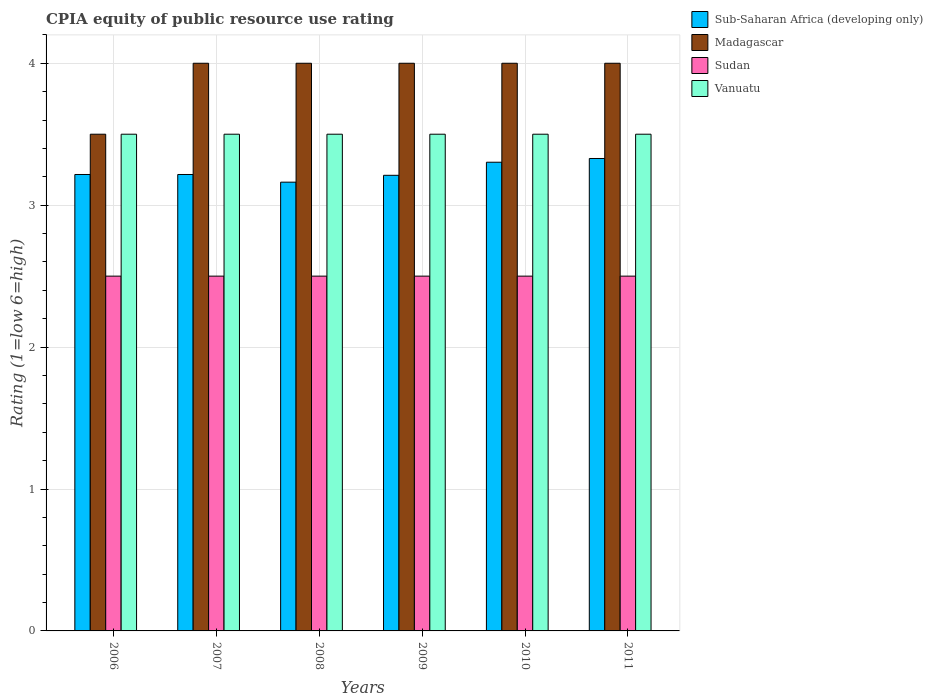How many groups of bars are there?
Your answer should be very brief. 6. Are the number of bars per tick equal to the number of legend labels?
Provide a succinct answer. Yes. How many bars are there on the 6th tick from the left?
Offer a very short reply. 4. How many bars are there on the 2nd tick from the right?
Provide a short and direct response. 4. In how many cases, is the number of bars for a given year not equal to the number of legend labels?
Provide a succinct answer. 0. What is the CPIA rating in Madagascar in 2008?
Give a very brief answer. 4. Across all years, what is the minimum CPIA rating in Vanuatu?
Your response must be concise. 3.5. In which year was the CPIA rating in Madagascar maximum?
Make the answer very short. 2007. What is the total CPIA rating in Vanuatu in the graph?
Provide a short and direct response. 21. What is the difference between the CPIA rating in Madagascar in 2007 and that in 2010?
Ensure brevity in your answer.  0. What is the difference between the CPIA rating in Sudan in 2010 and the CPIA rating in Madagascar in 2006?
Make the answer very short. -1. What is the average CPIA rating in Sub-Saharan Africa (developing only) per year?
Make the answer very short. 3.24. In the year 2008, what is the difference between the CPIA rating in Sub-Saharan Africa (developing only) and CPIA rating in Vanuatu?
Offer a terse response. -0.34. Is the difference between the CPIA rating in Sub-Saharan Africa (developing only) in 2008 and 2011 greater than the difference between the CPIA rating in Vanuatu in 2008 and 2011?
Offer a terse response. No. Is the sum of the CPIA rating in Vanuatu in 2010 and 2011 greater than the maximum CPIA rating in Sub-Saharan Africa (developing only) across all years?
Keep it short and to the point. Yes. Is it the case that in every year, the sum of the CPIA rating in Vanuatu and CPIA rating in Sudan is greater than the sum of CPIA rating in Sub-Saharan Africa (developing only) and CPIA rating in Madagascar?
Keep it short and to the point. No. What does the 3rd bar from the left in 2010 represents?
Your answer should be compact. Sudan. What does the 2nd bar from the right in 2006 represents?
Ensure brevity in your answer.  Sudan. Is it the case that in every year, the sum of the CPIA rating in Madagascar and CPIA rating in Vanuatu is greater than the CPIA rating in Sudan?
Provide a short and direct response. Yes. How many bars are there?
Your answer should be very brief. 24. What is the difference between two consecutive major ticks on the Y-axis?
Offer a terse response. 1. Are the values on the major ticks of Y-axis written in scientific E-notation?
Offer a terse response. No. Does the graph contain grids?
Ensure brevity in your answer.  Yes. Where does the legend appear in the graph?
Offer a very short reply. Top right. How many legend labels are there?
Offer a very short reply. 4. What is the title of the graph?
Keep it short and to the point. CPIA equity of public resource use rating. What is the label or title of the X-axis?
Offer a very short reply. Years. What is the label or title of the Y-axis?
Provide a short and direct response. Rating (1=low 6=high). What is the Rating (1=low 6=high) of Sub-Saharan Africa (developing only) in 2006?
Your response must be concise. 3.22. What is the Rating (1=low 6=high) of Sub-Saharan Africa (developing only) in 2007?
Keep it short and to the point. 3.22. What is the Rating (1=low 6=high) of Vanuatu in 2007?
Keep it short and to the point. 3.5. What is the Rating (1=low 6=high) of Sub-Saharan Africa (developing only) in 2008?
Give a very brief answer. 3.16. What is the Rating (1=low 6=high) in Madagascar in 2008?
Provide a succinct answer. 4. What is the Rating (1=low 6=high) in Sub-Saharan Africa (developing only) in 2009?
Ensure brevity in your answer.  3.21. What is the Rating (1=low 6=high) of Sudan in 2009?
Make the answer very short. 2.5. What is the Rating (1=low 6=high) in Sub-Saharan Africa (developing only) in 2010?
Your response must be concise. 3.3. What is the Rating (1=low 6=high) in Madagascar in 2010?
Offer a very short reply. 4. What is the Rating (1=low 6=high) of Sub-Saharan Africa (developing only) in 2011?
Give a very brief answer. 3.33. What is the Rating (1=low 6=high) in Madagascar in 2011?
Your answer should be very brief. 4. What is the Rating (1=low 6=high) of Sudan in 2011?
Your answer should be very brief. 2.5. What is the Rating (1=low 6=high) of Vanuatu in 2011?
Provide a succinct answer. 3.5. Across all years, what is the maximum Rating (1=low 6=high) of Sub-Saharan Africa (developing only)?
Ensure brevity in your answer.  3.33. Across all years, what is the maximum Rating (1=low 6=high) in Madagascar?
Offer a terse response. 4. Across all years, what is the maximum Rating (1=low 6=high) of Vanuatu?
Your answer should be very brief. 3.5. Across all years, what is the minimum Rating (1=low 6=high) of Sub-Saharan Africa (developing only)?
Your answer should be very brief. 3.16. Across all years, what is the minimum Rating (1=low 6=high) in Madagascar?
Offer a very short reply. 3.5. Across all years, what is the minimum Rating (1=low 6=high) in Vanuatu?
Your response must be concise. 3.5. What is the total Rating (1=low 6=high) in Sub-Saharan Africa (developing only) in the graph?
Offer a very short reply. 19.44. What is the total Rating (1=low 6=high) of Madagascar in the graph?
Provide a succinct answer. 23.5. What is the total Rating (1=low 6=high) of Sudan in the graph?
Provide a succinct answer. 15. What is the difference between the Rating (1=low 6=high) of Madagascar in 2006 and that in 2007?
Make the answer very short. -0.5. What is the difference between the Rating (1=low 6=high) in Sudan in 2006 and that in 2007?
Your answer should be very brief. 0. What is the difference between the Rating (1=low 6=high) of Sub-Saharan Africa (developing only) in 2006 and that in 2008?
Keep it short and to the point. 0.05. What is the difference between the Rating (1=low 6=high) of Sudan in 2006 and that in 2008?
Give a very brief answer. 0. What is the difference between the Rating (1=low 6=high) in Vanuatu in 2006 and that in 2008?
Your answer should be very brief. 0. What is the difference between the Rating (1=low 6=high) of Sub-Saharan Africa (developing only) in 2006 and that in 2009?
Ensure brevity in your answer.  0.01. What is the difference between the Rating (1=low 6=high) of Madagascar in 2006 and that in 2009?
Provide a short and direct response. -0.5. What is the difference between the Rating (1=low 6=high) in Vanuatu in 2006 and that in 2009?
Your response must be concise. 0. What is the difference between the Rating (1=low 6=high) of Sub-Saharan Africa (developing only) in 2006 and that in 2010?
Your answer should be very brief. -0.09. What is the difference between the Rating (1=low 6=high) of Vanuatu in 2006 and that in 2010?
Ensure brevity in your answer.  0. What is the difference between the Rating (1=low 6=high) in Sub-Saharan Africa (developing only) in 2006 and that in 2011?
Make the answer very short. -0.11. What is the difference between the Rating (1=low 6=high) in Madagascar in 2006 and that in 2011?
Offer a terse response. -0.5. What is the difference between the Rating (1=low 6=high) in Sudan in 2006 and that in 2011?
Your answer should be very brief. 0. What is the difference between the Rating (1=low 6=high) in Sub-Saharan Africa (developing only) in 2007 and that in 2008?
Your response must be concise. 0.05. What is the difference between the Rating (1=low 6=high) in Madagascar in 2007 and that in 2008?
Offer a very short reply. 0. What is the difference between the Rating (1=low 6=high) in Sudan in 2007 and that in 2008?
Your answer should be compact. 0. What is the difference between the Rating (1=low 6=high) of Sub-Saharan Africa (developing only) in 2007 and that in 2009?
Offer a terse response. 0.01. What is the difference between the Rating (1=low 6=high) of Vanuatu in 2007 and that in 2009?
Your answer should be very brief. 0. What is the difference between the Rating (1=low 6=high) in Sub-Saharan Africa (developing only) in 2007 and that in 2010?
Provide a short and direct response. -0.09. What is the difference between the Rating (1=low 6=high) of Madagascar in 2007 and that in 2010?
Your answer should be very brief. 0. What is the difference between the Rating (1=low 6=high) of Sudan in 2007 and that in 2010?
Your answer should be compact. 0. What is the difference between the Rating (1=low 6=high) in Sub-Saharan Africa (developing only) in 2007 and that in 2011?
Your response must be concise. -0.11. What is the difference between the Rating (1=low 6=high) of Madagascar in 2007 and that in 2011?
Ensure brevity in your answer.  0. What is the difference between the Rating (1=low 6=high) of Sub-Saharan Africa (developing only) in 2008 and that in 2009?
Offer a terse response. -0.05. What is the difference between the Rating (1=low 6=high) of Sudan in 2008 and that in 2009?
Provide a succinct answer. 0. What is the difference between the Rating (1=low 6=high) of Vanuatu in 2008 and that in 2009?
Provide a short and direct response. 0. What is the difference between the Rating (1=low 6=high) in Sub-Saharan Africa (developing only) in 2008 and that in 2010?
Ensure brevity in your answer.  -0.14. What is the difference between the Rating (1=low 6=high) in Madagascar in 2008 and that in 2010?
Give a very brief answer. 0. What is the difference between the Rating (1=low 6=high) of Sudan in 2008 and that in 2010?
Offer a very short reply. 0. What is the difference between the Rating (1=low 6=high) in Vanuatu in 2008 and that in 2010?
Your answer should be very brief. 0. What is the difference between the Rating (1=low 6=high) of Sub-Saharan Africa (developing only) in 2008 and that in 2011?
Give a very brief answer. -0.17. What is the difference between the Rating (1=low 6=high) in Vanuatu in 2008 and that in 2011?
Your response must be concise. 0. What is the difference between the Rating (1=low 6=high) of Sub-Saharan Africa (developing only) in 2009 and that in 2010?
Offer a very short reply. -0.09. What is the difference between the Rating (1=low 6=high) of Vanuatu in 2009 and that in 2010?
Provide a succinct answer. 0. What is the difference between the Rating (1=low 6=high) of Sub-Saharan Africa (developing only) in 2009 and that in 2011?
Make the answer very short. -0.12. What is the difference between the Rating (1=low 6=high) of Madagascar in 2009 and that in 2011?
Provide a short and direct response. 0. What is the difference between the Rating (1=low 6=high) of Sudan in 2009 and that in 2011?
Provide a succinct answer. 0. What is the difference between the Rating (1=low 6=high) of Vanuatu in 2009 and that in 2011?
Your answer should be very brief. 0. What is the difference between the Rating (1=low 6=high) of Sub-Saharan Africa (developing only) in 2010 and that in 2011?
Provide a short and direct response. -0.03. What is the difference between the Rating (1=low 6=high) in Madagascar in 2010 and that in 2011?
Make the answer very short. 0. What is the difference between the Rating (1=low 6=high) of Vanuatu in 2010 and that in 2011?
Ensure brevity in your answer.  0. What is the difference between the Rating (1=low 6=high) of Sub-Saharan Africa (developing only) in 2006 and the Rating (1=low 6=high) of Madagascar in 2007?
Give a very brief answer. -0.78. What is the difference between the Rating (1=low 6=high) of Sub-Saharan Africa (developing only) in 2006 and the Rating (1=low 6=high) of Sudan in 2007?
Ensure brevity in your answer.  0.72. What is the difference between the Rating (1=low 6=high) in Sub-Saharan Africa (developing only) in 2006 and the Rating (1=low 6=high) in Vanuatu in 2007?
Make the answer very short. -0.28. What is the difference between the Rating (1=low 6=high) in Madagascar in 2006 and the Rating (1=low 6=high) in Vanuatu in 2007?
Your response must be concise. 0. What is the difference between the Rating (1=low 6=high) in Sudan in 2006 and the Rating (1=low 6=high) in Vanuatu in 2007?
Your answer should be compact. -1. What is the difference between the Rating (1=low 6=high) of Sub-Saharan Africa (developing only) in 2006 and the Rating (1=low 6=high) of Madagascar in 2008?
Make the answer very short. -0.78. What is the difference between the Rating (1=low 6=high) in Sub-Saharan Africa (developing only) in 2006 and the Rating (1=low 6=high) in Sudan in 2008?
Offer a terse response. 0.72. What is the difference between the Rating (1=low 6=high) of Sub-Saharan Africa (developing only) in 2006 and the Rating (1=low 6=high) of Vanuatu in 2008?
Ensure brevity in your answer.  -0.28. What is the difference between the Rating (1=low 6=high) of Sub-Saharan Africa (developing only) in 2006 and the Rating (1=low 6=high) of Madagascar in 2009?
Offer a terse response. -0.78. What is the difference between the Rating (1=low 6=high) in Sub-Saharan Africa (developing only) in 2006 and the Rating (1=low 6=high) in Sudan in 2009?
Offer a very short reply. 0.72. What is the difference between the Rating (1=low 6=high) of Sub-Saharan Africa (developing only) in 2006 and the Rating (1=low 6=high) of Vanuatu in 2009?
Give a very brief answer. -0.28. What is the difference between the Rating (1=low 6=high) in Madagascar in 2006 and the Rating (1=low 6=high) in Sudan in 2009?
Your answer should be very brief. 1. What is the difference between the Rating (1=low 6=high) of Madagascar in 2006 and the Rating (1=low 6=high) of Vanuatu in 2009?
Offer a very short reply. 0. What is the difference between the Rating (1=low 6=high) of Sub-Saharan Africa (developing only) in 2006 and the Rating (1=low 6=high) of Madagascar in 2010?
Provide a succinct answer. -0.78. What is the difference between the Rating (1=low 6=high) in Sub-Saharan Africa (developing only) in 2006 and the Rating (1=low 6=high) in Sudan in 2010?
Give a very brief answer. 0.72. What is the difference between the Rating (1=low 6=high) of Sub-Saharan Africa (developing only) in 2006 and the Rating (1=low 6=high) of Vanuatu in 2010?
Make the answer very short. -0.28. What is the difference between the Rating (1=low 6=high) in Sudan in 2006 and the Rating (1=low 6=high) in Vanuatu in 2010?
Provide a short and direct response. -1. What is the difference between the Rating (1=low 6=high) in Sub-Saharan Africa (developing only) in 2006 and the Rating (1=low 6=high) in Madagascar in 2011?
Your response must be concise. -0.78. What is the difference between the Rating (1=low 6=high) in Sub-Saharan Africa (developing only) in 2006 and the Rating (1=low 6=high) in Sudan in 2011?
Ensure brevity in your answer.  0.72. What is the difference between the Rating (1=low 6=high) in Sub-Saharan Africa (developing only) in 2006 and the Rating (1=low 6=high) in Vanuatu in 2011?
Provide a succinct answer. -0.28. What is the difference between the Rating (1=low 6=high) of Madagascar in 2006 and the Rating (1=low 6=high) of Sudan in 2011?
Your response must be concise. 1. What is the difference between the Rating (1=low 6=high) in Sudan in 2006 and the Rating (1=low 6=high) in Vanuatu in 2011?
Keep it short and to the point. -1. What is the difference between the Rating (1=low 6=high) of Sub-Saharan Africa (developing only) in 2007 and the Rating (1=low 6=high) of Madagascar in 2008?
Keep it short and to the point. -0.78. What is the difference between the Rating (1=low 6=high) in Sub-Saharan Africa (developing only) in 2007 and the Rating (1=low 6=high) in Sudan in 2008?
Keep it short and to the point. 0.72. What is the difference between the Rating (1=low 6=high) of Sub-Saharan Africa (developing only) in 2007 and the Rating (1=low 6=high) of Vanuatu in 2008?
Offer a terse response. -0.28. What is the difference between the Rating (1=low 6=high) of Madagascar in 2007 and the Rating (1=low 6=high) of Sudan in 2008?
Offer a very short reply. 1.5. What is the difference between the Rating (1=low 6=high) in Madagascar in 2007 and the Rating (1=low 6=high) in Vanuatu in 2008?
Your response must be concise. 0.5. What is the difference between the Rating (1=low 6=high) of Sudan in 2007 and the Rating (1=low 6=high) of Vanuatu in 2008?
Provide a succinct answer. -1. What is the difference between the Rating (1=low 6=high) of Sub-Saharan Africa (developing only) in 2007 and the Rating (1=low 6=high) of Madagascar in 2009?
Provide a short and direct response. -0.78. What is the difference between the Rating (1=low 6=high) in Sub-Saharan Africa (developing only) in 2007 and the Rating (1=low 6=high) in Sudan in 2009?
Keep it short and to the point. 0.72. What is the difference between the Rating (1=low 6=high) of Sub-Saharan Africa (developing only) in 2007 and the Rating (1=low 6=high) of Vanuatu in 2009?
Provide a short and direct response. -0.28. What is the difference between the Rating (1=low 6=high) of Madagascar in 2007 and the Rating (1=low 6=high) of Vanuatu in 2009?
Provide a succinct answer. 0.5. What is the difference between the Rating (1=low 6=high) in Sub-Saharan Africa (developing only) in 2007 and the Rating (1=low 6=high) in Madagascar in 2010?
Offer a very short reply. -0.78. What is the difference between the Rating (1=low 6=high) of Sub-Saharan Africa (developing only) in 2007 and the Rating (1=low 6=high) of Sudan in 2010?
Offer a very short reply. 0.72. What is the difference between the Rating (1=low 6=high) of Sub-Saharan Africa (developing only) in 2007 and the Rating (1=low 6=high) of Vanuatu in 2010?
Keep it short and to the point. -0.28. What is the difference between the Rating (1=low 6=high) of Madagascar in 2007 and the Rating (1=low 6=high) of Vanuatu in 2010?
Give a very brief answer. 0.5. What is the difference between the Rating (1=low 6=high) of Sudan in 2007 and the Rating (1=low 6=high) of Vanuatu in 2010?
Your answer should be very brief. -1. What is the difference between the Rating (1=low 6=high) in Sub-Saharan Africa (developing only) in 2007 and the Rating (1=low 6=high) in Madagascar in 2011?
Offer a very short reply. -0.78. What is the difference between the Rating (1=low 6=high) in Sub-Saharan Africa (developing only) in 2007 and the Rating (1=low 6=high) in Sudan in 2011?
Ensure brevity in your answer.  0.72. What is the difference between the Rating (1=low 6=high) in Sub-Saharan Africa (developing only) in 2007 and the Rating (1=low 6=high) in Vanuatu in 2011?
Offer a terse response. -0.28. What is the difference between the Rating (1=low 6=high) of Sub-Saharan Africa (developing only) in 2008 and the Rating (1=low 6=high) of Madagascar in 2009?
Give a very brief answer. -0.84. What is the difference between the Rating (1=low 6=high) of Sub-Saharan Africa (developing only) in 2008 and the Rating (1=low 6=high) of Sudan in 2009?
Offer a very short reply. 0.66. What is the difference between the Rating (1=low 6=high) in Sub-Saharan Africa (developing only) in 2008 and the Rating (1=low 6=high) in Vanuatu in 2009?
Keep it short and to the point. -0.34. What is the difference between the Rating (1=low 6=high) of Madagascar in 2008 and the Rating (1=low 6=high) of Sudan in 2009?
Give a very brief answer. 1.5. What is the difference between the Rating (1=low 6=high) in Madagascar in 2008 and the Rating (1=low 6=high) in Vanuatu in 2009?
Give a very brief answer. 0.5. What is the difference between the Rating (1=low 6=high) of Sub-Saharan Africa (developing only) in 2008 and the Rating (1=low 6=high) of Madagascar in 2010?
Your response must be concise. -0.84. What is the difference between the Rating (1=low 6=high) of Sub-Saharan Africa (developing only) in 2008 and the Rating (1=low 6=high) of Sudan in 2010?
Offer a terse response. 0.66. What is the difference between the Rating (1=low 6=high) of Sub-Saharan Africa (developing only) in 2008 and the Rating (1=low 6=high) of Vanuatu in 2010?
Give a very brief answer. -0.34. What is the difference between the Rating (1=low 6=high) of Madagascar in 2008 and the Rating (1=low 6=high) of Sudan in 2010?
Give a very brief answer. 1.5. What is the difference between the Rating (1=low 6=high) of Madagascar in 2008 and the Rating (1=low 6=high) of Vanuatu in 2010?
Give a very brief answer. 0.5. What is the difference between the Rating (1=low 6=high) of Sudan in 2008 and the Rating (1=low 6=high) of Vanuatu in 2010?
Provide a short and direct response. -1. What is the difference between the Rating (1=low 6=high) of Sub-Saharan Africa (developing only) in 2008 and the Rating (1=low 6=high) of Madagascar in 2011?
Your answer should be very brief. -0.84. What is the difference between the Rating (1=low 6=high) in Sub-Saharan Africa (developing only) in 2008 and the Rating (1=low 6=high) in Sudan in 2011?
Provide a succinct answer. 0.66. What is the difference between the Rating (1=low 6=high) of Sub-Saharan Africa (developing only) in 2008 and the Rating (1=low 6=high) of Vanuatu in 2011?
Your answer should be very brief. -0.34. What is the difference between the Rating (1=low 6=high) in Sudan in 2008 and the Rating (1=low 6=high) in Vanuatu in 2011?
Offer a very short reply. -1. What is the difference between the Rating (1=low 6=high) of Sub-Saharan Africa (developing only) in 2009 and the Rating (1=low 6=high) of Madagascar in 2010?
Offer a terse response. -0.79. What is the difference between the Rating (1=low 6=high) in Sub-Saharan Africa (developing only) in 2009 and the Rating (1=low 6=high) in Sudan in 2010?
Make the answer very short. 0.71. What is the difference between the Rating (1=low 6=high) of Sub-Saharan Africa (developing only) in 2009 and the Rating (1=low 6=high) of Vanuatu in 2010?
Keep it short and to the point. -0.29. What is the difference between the Rating (1=low 6=high) in Madagascar in 2009 and the Rating (1=low 6=high) in Sudan in 2010?
Give a very brief answer. 1.5. What is the difference between the Rating (1=low 6=high) in Madagascar in 2009 and the Rating (1=low 6=high) in Vanuatu in 2010?
Provide a succinct answer. 0.5. What is the difference between the Rating (1=low 6=high) of Sudan in 2009 and the Rating (1=low 6=high) of Vanuatu in 2010?
Ensure brevity in your answer.  -1. What is the difference between the Rating (1=low 6=high) of Sub-Saharan Africa (developing only) in 2009 and the Rating (1=low 6=high) of Madagascar in 2011?
Your answer should be compact. -0.79. What is the difference between the Rating (1=low 6=high) of Sub-Saharan Africa (developing only) in 2009 and the Rating (1=low 6=high) of Sudan in 2011?
Your answer should be compact. 0.71. What is the difference between the Rating (1=low 6=high) of Sub-Saharan Africa (developing only) in 2009 and the Rating (1=low 6=high) of Vanuatu in 2011?
Your response must be concise. -0.29. What is the difference between the Rating (1=low 6=high) of Madagascar in 2009 and the Rating (1=low 6=high) of Sudan in 2011?
Give a very brief answer. 1.5. What is the difference between the Rating (1=low 6=high) of Madagascar in 2009 and the Rating (1=low 6=high) of Vanuatu in 2011?
Your response must be concise. 0.5. What is the difference between the Rating (1=low 6=high) in Sub-Saharan Africa (developing only) in 2010 and the Rating (1=low 6=high) in Madagascar in 2011?
Offer a terse response. -0.7. What is the difference between the Rating (1=low 6=high) in Sub-Saharan Africa (developing only) in 2010 and the Rating (1=low 6=high) in Sudan in 2011?
Your answer should be compact. 0.8. What is the difference between the Rating (1=low 6=high) in Sub-Saharan Africa (developing only) in 2010 and the Rating (1=low 6=high) in Vanuatu in 2011?
Make the answer very short. -0.2. What is the difference between the Rating (1=low 6=high) of Madagascar in 2010 and the Rating (1=low 6=high) of Sudan in 2011?
Make the answer very short. 1.5. What is the difference between the Rating (1=low 6=high) of Sudan in 2010 and the Rating (1=low 6=high) of Vanuatu in 2011?
Your response must be concise. -1. What is the average Rating (1=low 6=high) of Sub-Saharan Africa (developing only) per year?
Your answer should be very brief. 3.24. What is the average Rating (1=low 6=high) of Madagascar per year?
Make the answer very short. 3.92. What is the average Rating (1=low 6=high) in Sudan per year?
Offer a terse response. 2.5. In the year 2006, what is the difference between the Rating (1=low 6=high) of Sub-Saharan Africa (developing only) and Rating (1=low 6=high) of Madagascar?
Offer a very short reply. -0.28. In the year 2006, what is the difference between the Rating (1=low 6=high) in Sub-Saharan Africa (developing only) and Rating (1=low 6=high) in Sudan?
Offer a terse response. 0.72. In the year 2006, what is the difference between the Rating (1=low 6=high) of Sub-Saharan Africa (developing only) and Rating (1=low 6=high) of Vanuatu?
Offer a terse response. -0.28. In the year 2007, what is the difference between the Rating (1=low 6=high) in Sub-Saharan Africa (developing only) and Rating (1=low 6=high) in Madagascar?
Your answer should be very brief. -0.78. In the year 2007, what is the difference between the Rating (1=low 6=high) of Sub-Saharan Africa (developing only) and Rating (1=low 6=high) of Sudan?
Provide a succinct answer. 0.72. In the year 2007, what is the difference between the Rating (1=low 6=high) in Sub-Saharan Africa (developing only) and Rating (1=low 6=high) in Vanuatu?
Give a very brief answer. -0.28. In the year 2008, what is the difference between the Rating (1=low 6=high) of Sub-Saharan Africa (developing only) and Rating (1=low 6=high) of Madagascar?
Keep it short and to the point. -0.84. In the year 2008, what is the difference between the Rating (1=low 6=high) in Sub-Saharan Africa (developing only) and Rating (1=low 6=high) in Sudan?
Keep it short and to the point. 0.66. In the year 2008, what is the difference between the Rating (1=low 6=high) of Sub-Saharan Africa (developing only) and Rating (1=low 6=high) of Vanuatu?
Give a very brief answer. -0.34. In the year 2008, what is the difference between the Rating (1=low 6=high) of Sudan and Rating (1=low 6=high) of Vanuatu?
Your response must be concise. -1. In the year 2009, what is the difference between the Rating (1=low 6=high) in Sub-Saharan Africa (developing only) and Rating (1=low 6=high) in Madagascar?
Ensure brevity in your answer.  -0.79. In the year 2009, what is the difference between the Rating (1=low 6=high) in Sub-Saharan Africa (developing only) and Rating (1=low 6=high) in Sudan?
Give a very brief answer. 0.71. In the year 2009, what is the difference between the Rating (1=low 6=high) in Sub-Saharan Africa (developing only) and Rating (1=low 6=high) in Vanuatu?
Your answer should be very brief. -0.29. In the year 2009, what is the difference between the Rating (1=low 6=high) of Madagascar and Rating (1=low 6=high) of Sudan?
Keep it short and to the point. 1.5. In the year 2010, what is the difference between the Rating (1=low 6=high) of Sub-Saharan Africa (developing only) and Rating (1=low 6=high) of Madagascar?
Offer a terse response. -0.7. In the year 2010, what is the difference between the Rating (1=low 6=high) in Sub-Saharan Africa (developing only) and Rating (1=low 6=high) in Sudan?
Your answer should be compact. 0.8. In the year 2010, what is the difference between the Rating (1=low 6=high) of Sub-Saharan Africa (developing only) and Rating (1=low 6=high) of Vanuatu?
Offer a terse response. -0.2. In the year 2010, what is the difference between the Rating (1=low 6=high) of Madagascar and Rating (1=low 6=high) of Sudan?
Provide a succinct answer. 1.5. In the year 2010, what is the difference between the Rating (1=low 6=high) in Sudan and Rating (1=low 6=high) in Vanuatu?
Your answer should be very brief. -1. In the year 2011, what is the difference between the Rating (1=low 6=high) in Sub-Saharan Africa (developing only) and Rating (1=low 6=high) in Madagascar?
Offer a very short reply. -0.67. In the year 2011, what is the difference between the Rating (1=low 6=high) in Sub-Saharan Africa (developing only) and Rating (1=low 6=high) in Sudan?
Your answer should be compact. 0.83. In the year 2011, what is the difference between the Rating (1=low 6=high) in Sub-Saharan Africa (developing only) and Rating (1=low 6=high) in Vanuatu?
Provide a succinct answer. -0.17. In the year 2011, what is the difference between the Rating (1=low 6=high) of Madagascar and Rating (1=low 6=high) of Vanuatu?
Ensure brevity in your answer.  0.5. What is the ratio of the Rating (1=low 6=high) of Madagascar in 2006 to that in 2007?
Give a very brief answer. 0.88. What is the ratio of the Rating (1=low 6=high) in Sudan in 2006 to that in 2007?
Your answer should be compact. 1. What is the ratio of the Rating (1=low 6=high) of Sub-Saharan Africa (developing only) in 2006 to that in 2008?
Make the answer very short. 1.02. What is the ratio of the Rating (1=low 6=high) in Vanuatu in 2006 to that in 2008?
Give a very brief answer. 1. What is the ratio of the Rating (1=low 6=high) of Sudan in 2006 to that in 2009?
Offer a very short reply. 1. What is the ratio of the Rating (1=low 6=high) of Sub-Saharan Africa (developing only) in 2006 to that in 2010?
Ensure brevity in your answer.  0.97. What is the ratio of the Rating (1=low 6=high) in Sudan in 2006 to that in 2010?
Your answer should be very brief. 1. What is the ratio of the Rating (1=low 6=high) in Sub-Saharan Africa (developing only) in 2006 to that in 2011?
Your response must be concise. 0.97. What is the ratio of the Rating (1=low 6=high) in Sudan in 2006 to that in 2011?
Ensure brevity in your answer.  1. What is the ratio of the Rating (1=low 6=high) of Vanuatu in 2006 to that in 2011?
Offer a very short reply. 1. What is the ratio of the Rating (1=low 6=high) of Sub-Saharan Africa (developing only) in 2007 to that in 2008?
Your answer should be very brief. 1.02. What is the ratio of the Rating (1=low 6=high) of Madagascar in 2007 to that in 2008?
Your answer should be compact. 1. What is the ratio of the Rating (1=low 6=high) in Vanuatu in 2007 to that in 2008?
Your answer should be very brief. 1. What is the ratio of the Rating (1=low 6=high) in Sub-Saharan Africa (developing only) in 2007 to that in 2009?
Keep it short and to the point. 1. What is the ratio of the Rating (1=low 6=high) of Madagascar in 2007 to that in 2009?
Your answer should be compact. 1. What is the ratio of the Rating (1=low 6=high) of Sudan in 2007 to that in 2009?
Offer a very short reply. 1. What is the ratio of the Rating (1=low 6=high) of Vanuatu in 2007 to that in 2009?
Provide a succinct answer. 1. What is the ratio of the Rating (1=low 6=high) in Sub-Saharan Africa (developing only) in 2007 to that in 2010?
Your answer should be very brief. 0.97. What is the ratio of the Rating (1=low 6=high) of Madagascar in 2007 to that in 2010?
Keep it short and to the point. 1. What is the ratio of the Rating (1=low 6=high) in Sudan in 2007 to that in 2010?
Ensure brevity in your answer.  1. What is the ratio of the Rating (1=low 6=high) in Sub-Saharan Africa (developing only) in 2007 to that in 2011?
Your answer should be very brief. 0.97. What is the ratio of the Rating (1=low 6=high) of Vanuatu in 2007 to that in 2011?
Give a very brief answer. 1. What is the ratio of the Rating (1=low 6=high) of Sub-Saharan Africa (developing only) in 2008 to that in 2009?
Your answer should be compact. 0.98. What is the ratio of the Rating (1=low 6=high) in Madagascar in 2008 to that in 2009?
Make the answer very short. 1. What is the ratio of the Rating (1=low 6=high) in Sudan in 2008 to that in 2009?
Make the answer very short. 1. What is the ratio of the Rating (1=low 6=high) in Vanuatu in 2008 to that in 2009?
Give a very brief answer. 1. What is the ratio of the Rating (1=low 6=high) of Sub-Saharan Africa (developing only) in 2008 to that in 2010?
Provide a short and direct response. 0.96. What is the ratio of the Rating (1=low 6=high) in Vanuatu in 2008 to that in 2010?
Your response must be concise. 1. What is the ratio of the Rating (1=low 6=high) in Sub-Saharan Africa (developing only) in 2008 to that in 2011?
Your answer should be compact. 0.95. What is the ratio of the Rating (1=low 6=high) of Madagascar in 2008 to that in 2011?
Your response must be concise. 1. What is the ratio of the Rating (1=low 6=high) of Vanuatu in 2008 to that in 2011?
Keep it short and to the point. 1. What is the ratio of the Rating (1=low 6=high) in Sub-Saharan Africa (developing only) in 2009 to that in 2010?
Make the answer very short. 0.97. What is the ratio of the Rating (1=low 6=high) of Vanuatu in 2009 to that in 2010?
Give a very brief answer. 1. What is the ratio of the Rating (1=low 6=high) in Sub-Saharan Africa (developing only) in 2009 to that in 2011?
Give a very brief answer. 0.96. What is the ratio of the Rating (1=low 6=high) of Madagascar in 2009 to that in 2011?
Provide a succinct answer. 1. What is the ratio of the Rating (1=low 6=high) in Sudan in 2009 to that in 2011?
Offer a very short reply. 1. What is the ratio of the Rating (1=low 6=high) in Vanuatu in 2010 to that in 2011?
Your answer should be compact. 1. What is the difference between the highest and the second highest Rating (1=low 6=high) of Sub-Saharan Africa (developing only)?
Your answer should be very brief. 0.03. What is the difference between the highest and the second highest Rating (1=low 6=high) of Madagascar?
Provide a succinct answer. 0. What is the difference between the highest and the second highest Rating (1=low 6=high) in Sudan?
Ensure brevity in your answer.  0. What is the difference between the highest and the lowest Rating (1=low 6=high) of Sub-Saharan Africa (developing only)?
Your response must be concise. 0.17. What is the difference between the highest and the lowest Rating (1=low 6=high) of Sudan?
Keep it short and to the point. 0. What is the difference between the highest and the lowest Rating (1=low 6=high) in Vanuatu?
Give a very brief answer. 0. 